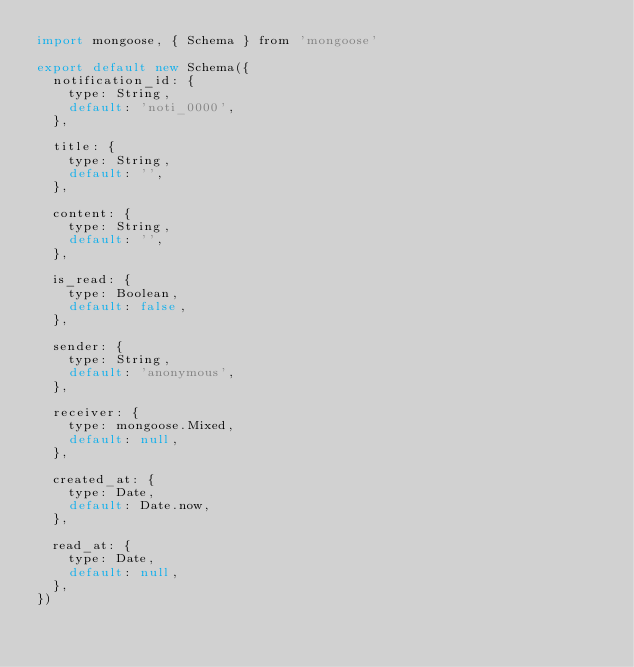<code> <loc_0><loc_0><loc_500><loc_500><_JavaScript_>import mongoose, { Schema } from 'mongoose'

export default new Schema({
  notification_id: {
    type: String,
    default: 'noti_0000',
  },

  title: {
    type: String,
    default: '',
  },

  content: {
    type: String,
    default: '',
  },

  is_read: {
    type: Boolean,
    default: false,
  },

  sender: {
    type: String,
    default: 'anonymous',
  },

  receiver: {
    type: mongoose.Mixed,
    default: null,
  },

  created_at: {
    type: Date,
    default: Date.now,
  },

  read_at: {
    type: Date,
    default: null,
  },
})</code> 